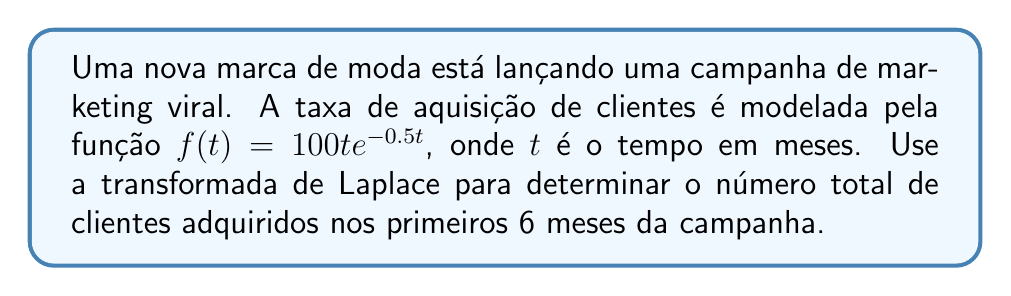What is the answer to this math problem? Para resolver este problema, seguiremos os seguintes passos:

1) A transformada de Laplace de $f(t) = 100te^{-0.5t}$ é dada por:

   $$\mathcal{L}\{f(t)\} = F(s) = \frac{100}{(s+0.5)^2}$$

2) Para encontrar o número total de clientes adquiridos, precisamos integrar $f(t)$ de 0 a 6. No domínio de Laplace, isso é equivalente a multiplicar $F(s)$ por $\frac{1-e^{-6s}}{s}$:

   $$G(s) = F(s) \cdot \frac{1-e^{-6s}}{s} = \frac{100}{(s+0.5)^2} \cdot \frac{1-e^{-6s}}{s}$$

3) Agora, precisamos calcular a transformada inversa de Laplace de $G(s)$ em $s=0$:

   $$\text{Total de clientes} = \lim_{s \to 0} sG(s) = \lim_{s \to 0} \frac{100(1-e^{-6s})}{s(s+0.5)^2}$$

4) Aplicando a regra de L'Hôpital três vezes (devido ao zero triplo no denominador), obtemos:

   $$\lim_{s \to 0} \frac{3600e^{-6s}}{(s+0.5)^2 - 4s(s+0.5) + 2s^2} = \frac{3600}{0.25} = 14400$$

Portanto, o número total de clientes adquiridos nos primeiros 6 meses é 14400.
Answer: 14400 clientes 